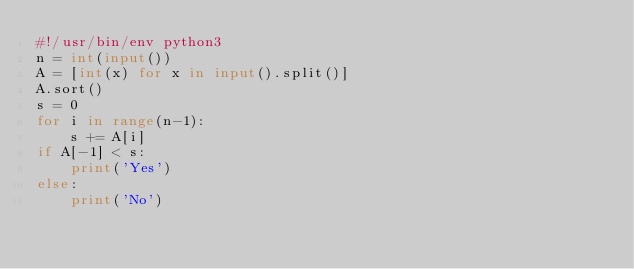Convert code to text. <code><loc_0><loc_0><loc_500><loc_500><_Python_>#!/usr/bin/env python3
n = int(input())
A = [int(x) for x in input().split()]
A.sort()
s = 0
for i in range(n-1):
    s += A[i]
if A[-1] < s:
    print('Yes')
else:
    print('No')</code> 